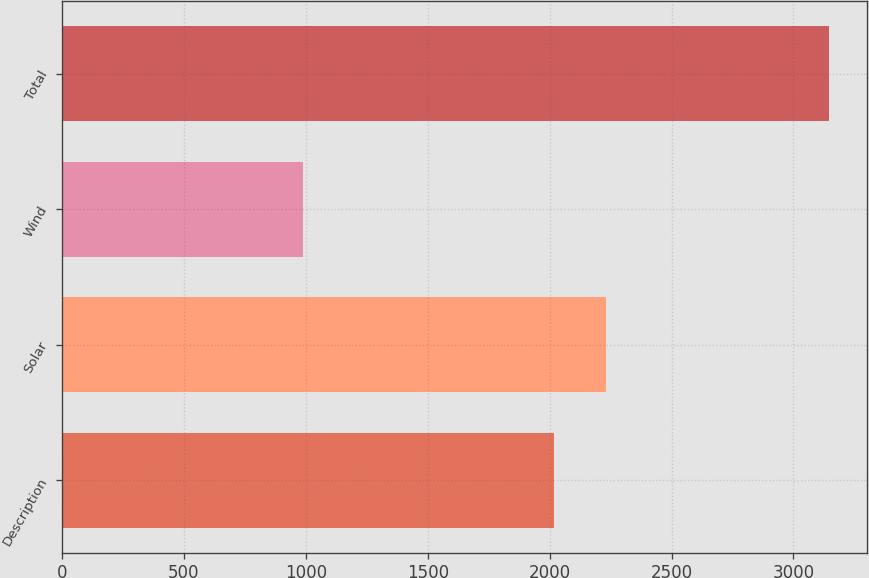<chart> <loc_0><loc_0><loc_500><loc_500><bar_chart><fcel>Description<fcel>Solar<fcel>Wind<fcel>Total<nl><fcel>2017<fcel>2232.8<fcel>988<fcel>3146<nl></chart> 